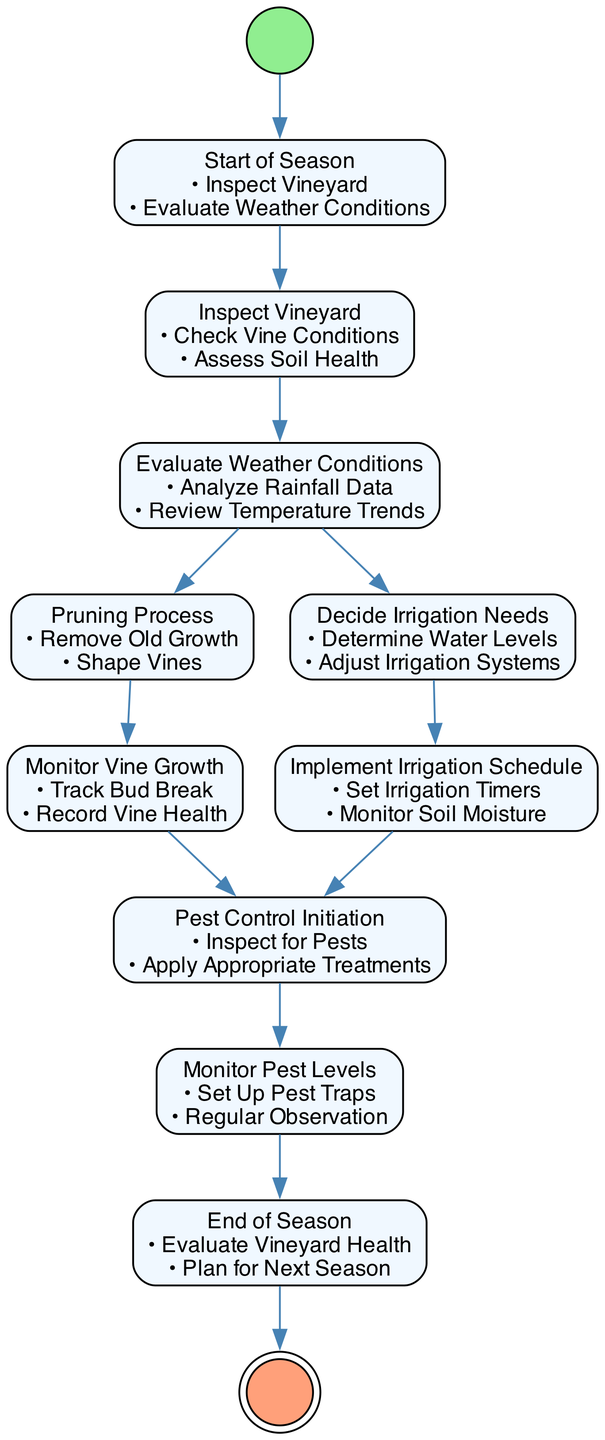What is the first activity in the diagram? The first activity is indicated as the starting point, labeled "Start of Season." This is the starting node that connects to "Inspect Vineyard."
Answer: Start of Season How many activities are shown in the diagram? To determine the total number of activities, I counted the individual nodes listed in the diagram. There are ten distinct activities represented.
Answer: Ten What actions are included in the "Pruning Process" activity? By examining the "Pruning Process" node, I identified two actions listed under it: "Remove Old Growth" and "Shape Vines." These actions define what occurs during this activity.
Answer: Remove Old Growth, Shape Vines What follows after the "Decide Irrigation Needs" activity? According to the diagram's flow, once the "Decide Irrigation Needs" activity is completed, the next activity is "Implement Irrigation Schedule," showing a direct transition in the process.
Answer: Implement Irrigation Schedule Which activity comes before "Pest Control Initiation"? I reviewed the transitions leading into the "Pest Control Initiation" node. Both "Implement Irrigation Schedule" and "Monitor Vine Growth" are direct predecessors to this activity, indicating multiple paths leading into it.
Answer: Implement Irrigation Schedule, Monitor Vine Growth What is the last activity in the diagram? The last activity, recognized by its position with no following transitions, is labeled "End of Season," indicating the conclusion of the seasonal vineyard maintenance process.
Answer: End of Season How does one initiate pest control? The initiation of pest control is outlined in its specific activity: "Pest Control Initiation," where the actions include "Inspect for Pests" and "Apply Appropriate Treatments." This signifies the start of pest control measures.
Answer: Inspect for Pests, Apply Appropriate Treatments How many transitions occur from the "Evaluate Weather Conditions" activity? By checking the outgoing connections from the "Evaluate Weather Conditions," I noted that there are two transitions leading to both "Pruning Process" and "Decide Irrigation Needs." This shows the branching options available after this evaluation.
Answer: Two What actions ensure irrigation after determining needs? Once the irrigation needs have been decided, the subsequent actions involved in the "Implement Irrigation Schedule" activity are "Set Irrigation Timers" and "Monitor Soil Moisture," which are crucial for effective irrigation management.
Answer: Set Irrigation Timers, Monitor Soil Moisture 